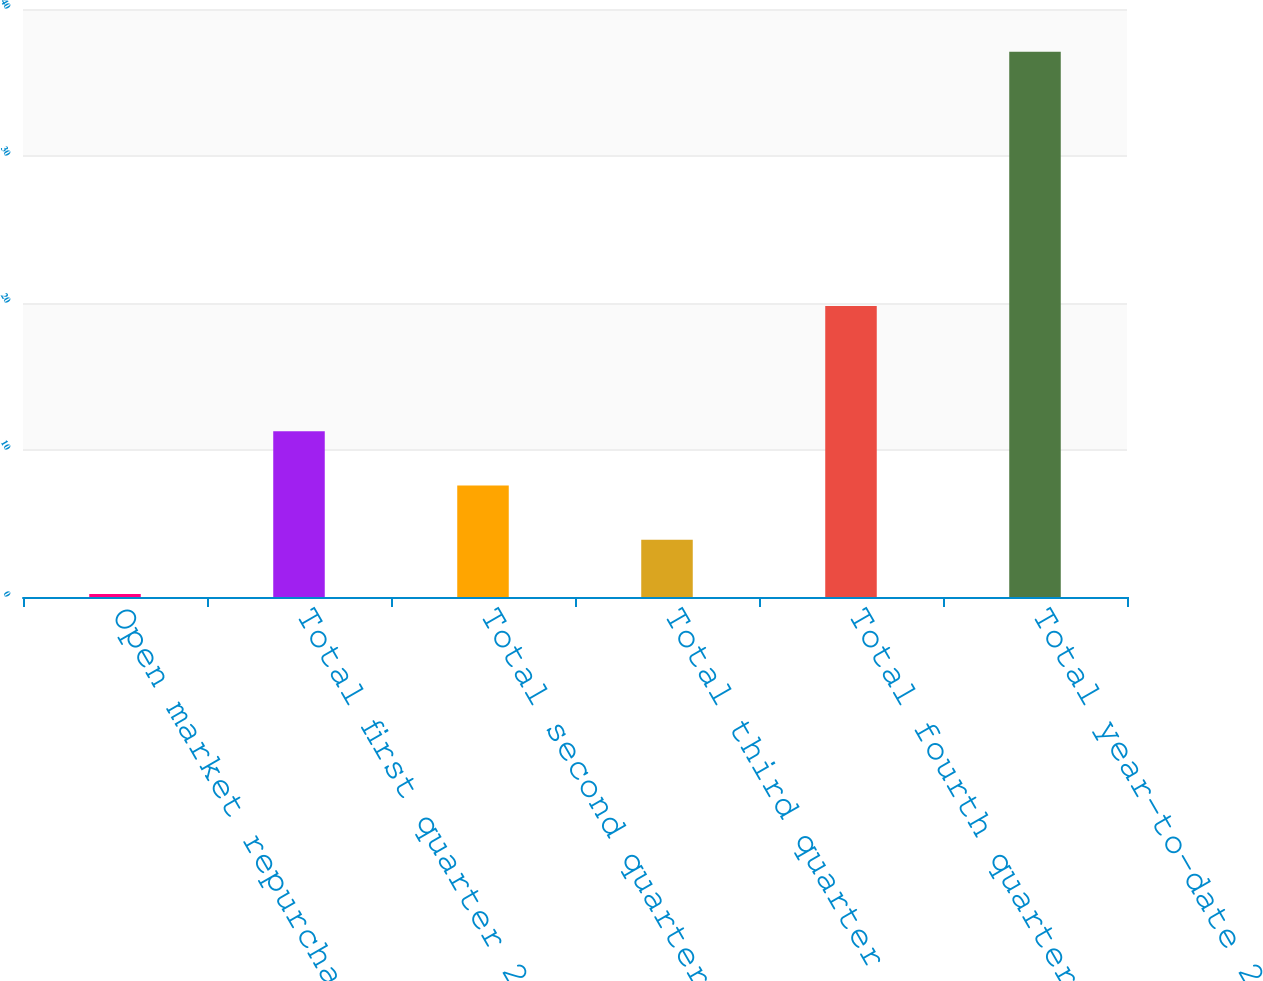Convert chart to OTSL. <chart><loc_0><loc_0><loc_500><loc_500><bar_chart><fcel>Open market repurchases (1)<fcel>Total first quarter 2009<fcel>Total second quarter 2009<fcel>Total third quarter 2009<fcel>Total fourth quarter 2009<fcel>Total year-to-date 2009<nl><fcel>0.2<fcel>11.27<fcel>7.58<fcel>3.89<fcel>19.8<fcel>37.1<nl></chart> 